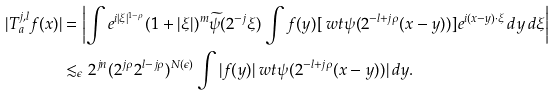Convert formula to latex. <formula><loc_0><loc_0><loc_500><loc_500>| T _ { a } ^ { j , l } f ( x ) | & = \left | \int e ^ { i | \xi | ^ { 1 - \rho } } ( 1 + | \xi | ) ^ { m } \widetilde { \psi } ( 2 ^ { - j } \xi ) \int f ( y ) [ \ w t { \psi } ( 2 ^ { - l + j \rho } ( x - y ) ) ] e ^ { i ( x - y ) \cdot \xi } \, d y \, d \xi \right | \\ & \lesssim _ { \epsilon } 2 ^ { j n } ( 2 ^ { j \rho } 2 ^ { l - j \rho } ) ^ { N ( \epsilon ) } \int | f ( y ) | \ w t { \psi } ( 2 ^ { - l + j \rho } ( x - y ) ) | \, d y .</formula> 